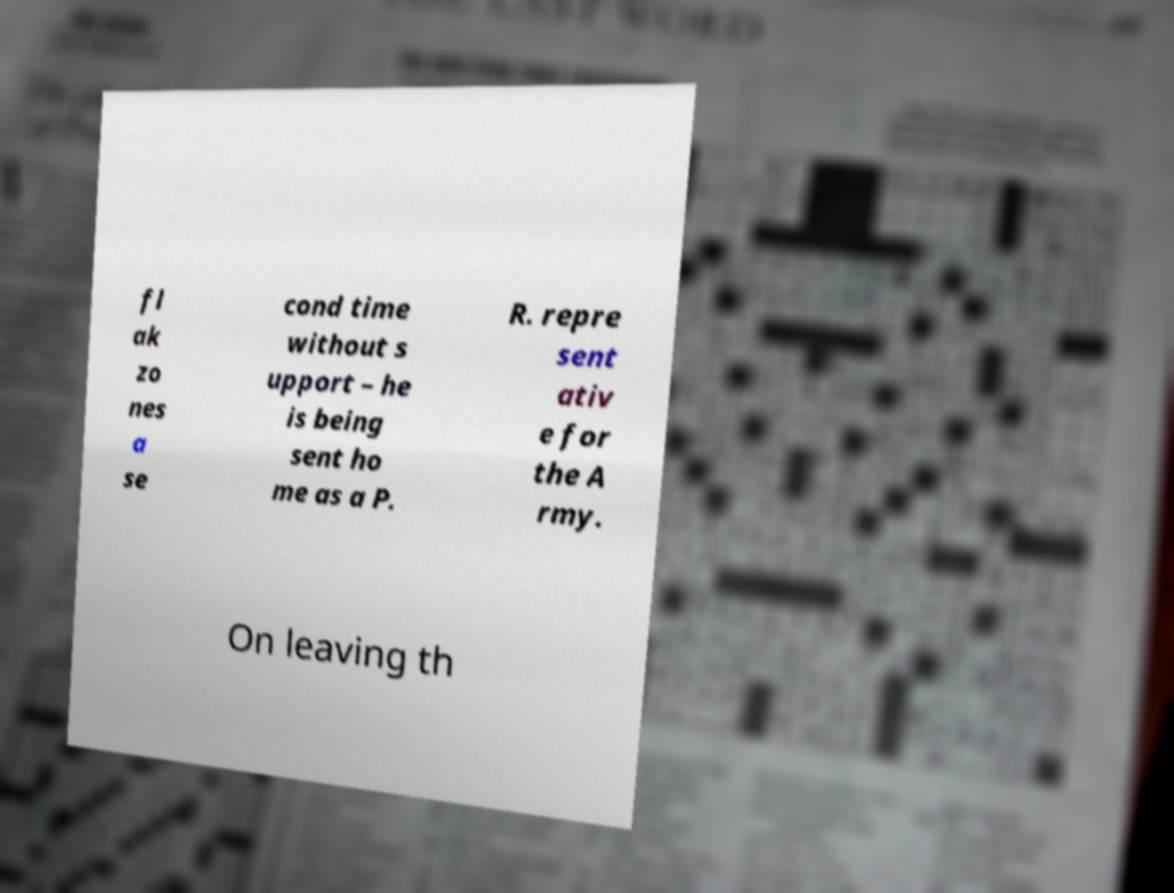Please identify and transcribe the text found in this image. fl ak zo nes a se cond time without s upport – he is being sent ho me as a P. R. repre sent ativ e for the A rmy. On leaving th 